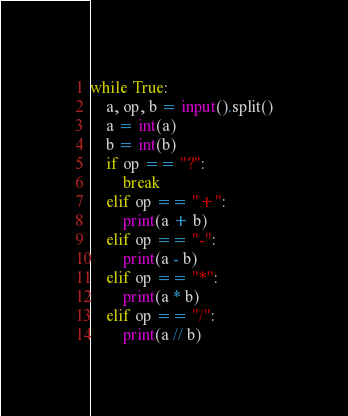Convert code to text. <code><loc_0><loc_0><loc_500><loc_500><_Python_>while True:
    a, op, b = input().split()
    a = int(a)
    b = int(b)
    if op == "?":
        break
    elif op == "+":
        print(a + b)
    elif op == "-":
        print(a - b)
    elif op == "*":
        print(a * b)
    elif op == "/":
        print(a // b)

</code> 